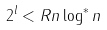Convert formula to latex. <formula><loc_0><loc_0><loc_500><loc_500>2 ^ { l } < R n \log ^ { * } n</formula> 